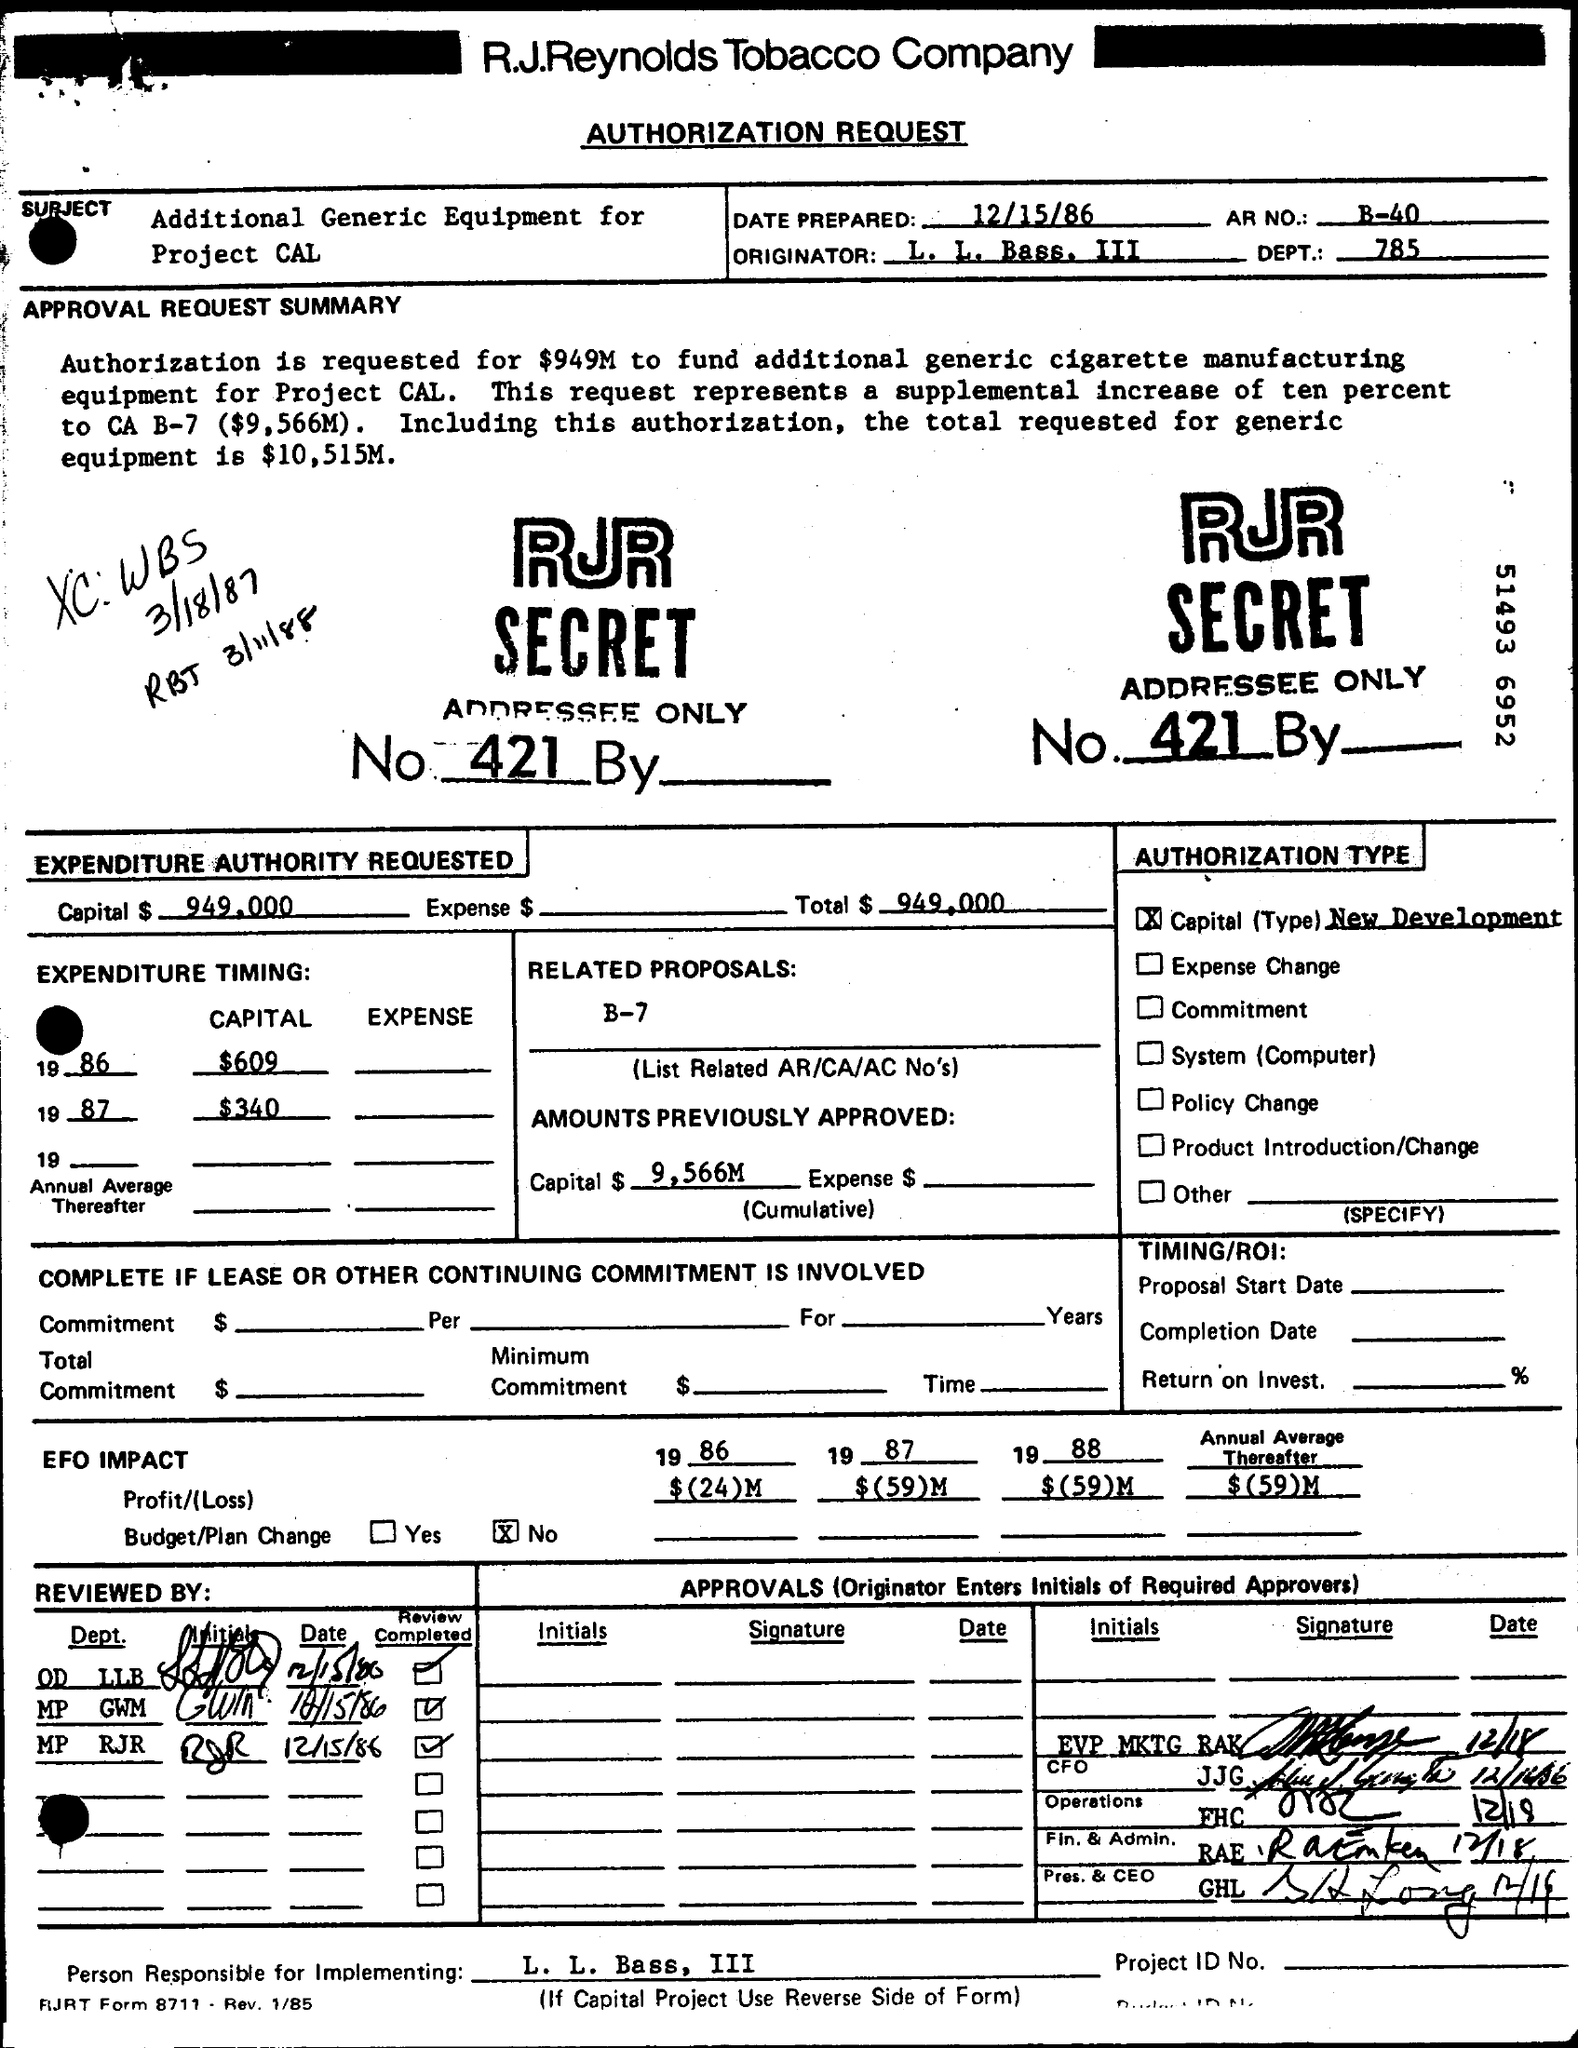List a handful of essential elements in this visual. The capital is $949,000. The profit for 1986 was $(24) million. The total is $949,000. In 1987, the profit or loss was $(59) million. What is the Date Prepared? The date prepared is December 15, 1986. 